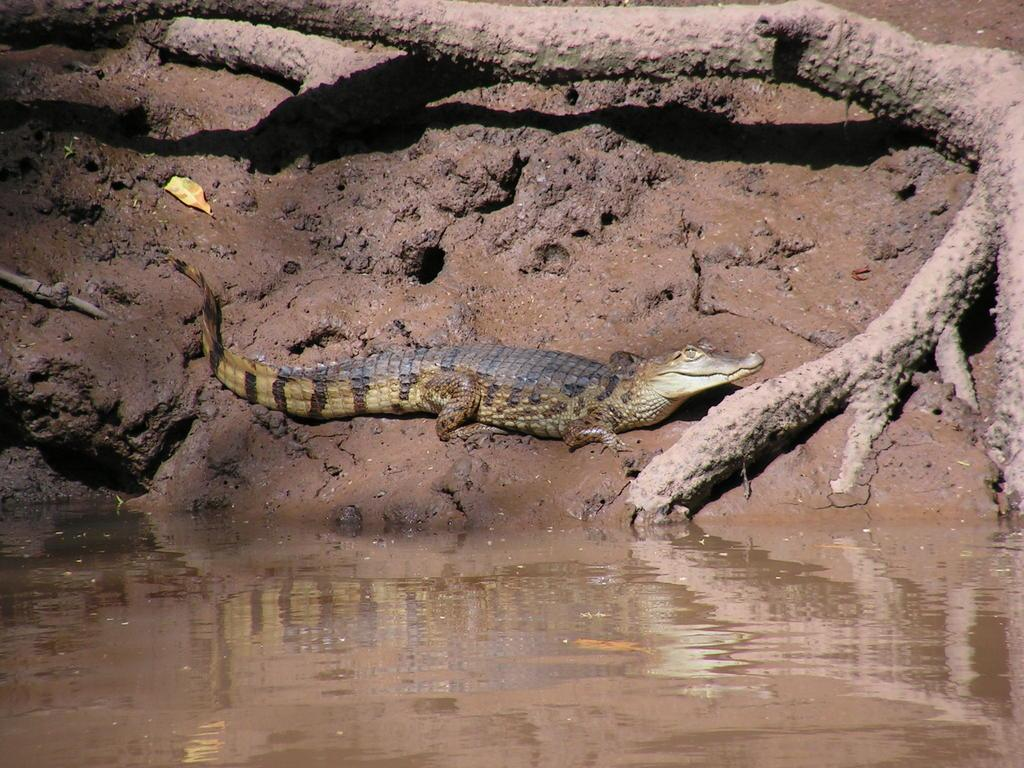What is located in the front of the image? There is water in the front of the image. What is the main subject in the center of the image? There is a crocodile in the center of the image. What can be seen in the background of the image? There are tree trunks in the background of the image. What type of terrain is visible in the image? There is wet soil visible in the image. Can you see a sail in the image? There is no sail present in the image. Is there a volleyball visible in the image? There is no volleyball present in the image. 